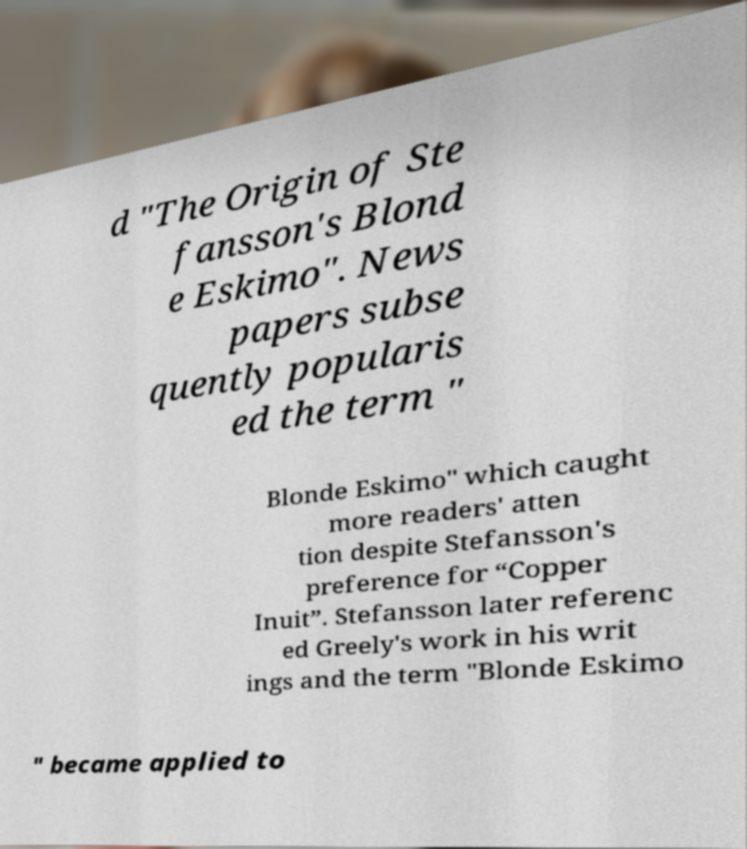Could you extract and type out the text from this image? d "The Origin of Ste fansson's Blond e Eskimo". News papers subse quently popularis ed the term " Blonde Eskimo" which caught more readers' atten tion despite Stefansson's preference for “Copper Inuit”. Stefansson later referenc ed Greely's work in his writ ings and the term "Blonde Eskimo " became applied to 